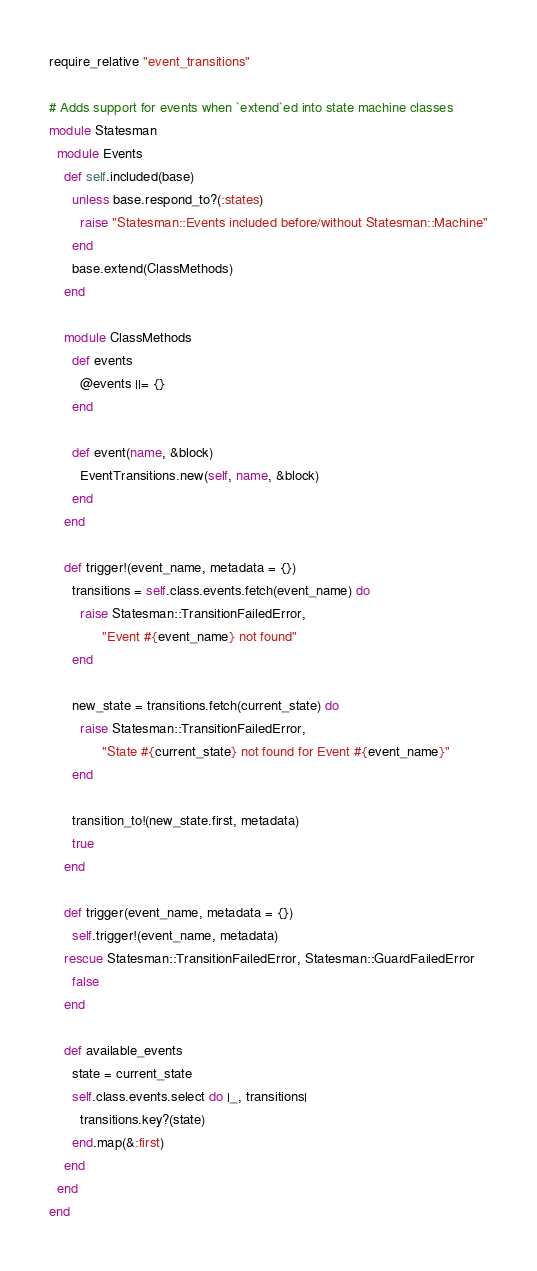Convert code to text. <code><loc_0><loc_0><loc_500><loc_500><_Ruby_>require_relative "event_transitions"

# Adds support for events when `extend`ed into state machine classes
module Statesman
  module Events
    def self.included(base)
      unless base.respond_to?(:states)
        raise "Statesman::Events included before/without Statesman::Machine"
      end
      base.extend(ClassMethods)
    end

    module ClassMethods
      def events
        @events ||= {}
      end

      def event(name, &block)
        EventTransitions.new(self, name, &block)
      end
    end

    def trigger!(event_name, metadata = {})
      transitions = self.class.events.fetch(event_name) do
        raise Statesman::TransitionFailedError,
              "Event #{event_name} not found"
      end

      new_state = transitions.fetch(current_state) do
        raise Statesman::TransitionFailedError,
              "State #{current_state} not found for Event #{event_name}"
      end

      transition_to!(new_state.first, metadata)
      true
    end

    def trigger(event_name, metadata = {})
      self.trigger!(event_name, metadata)
    rescue Statesman::TransitionFailedError, Statesman::GuardFailedError
      false
    end

    def available_events
      state = current_state
      self.class.events.select do |_, transitions|
        transitions.key?(state)
      end.map(&:first)
    end
  end
end
</code> 